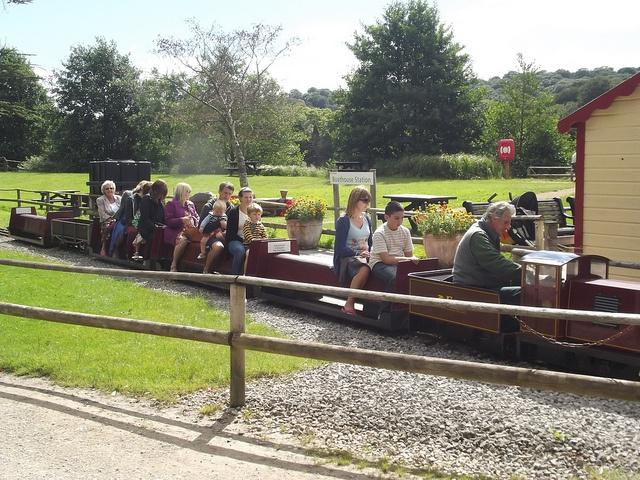Describe the objects in this image and their specific colors. I can see train in lightblue, black, gray, and white tones, people in lightblue, black, gray, white, and darkgray tones, people in lightblue, gray, black, and darkgray tones, people in lightblue, darkgray, black, and gray tones, and potted plant in lightblue, olive, gray, and darkgreen tones in this image. 